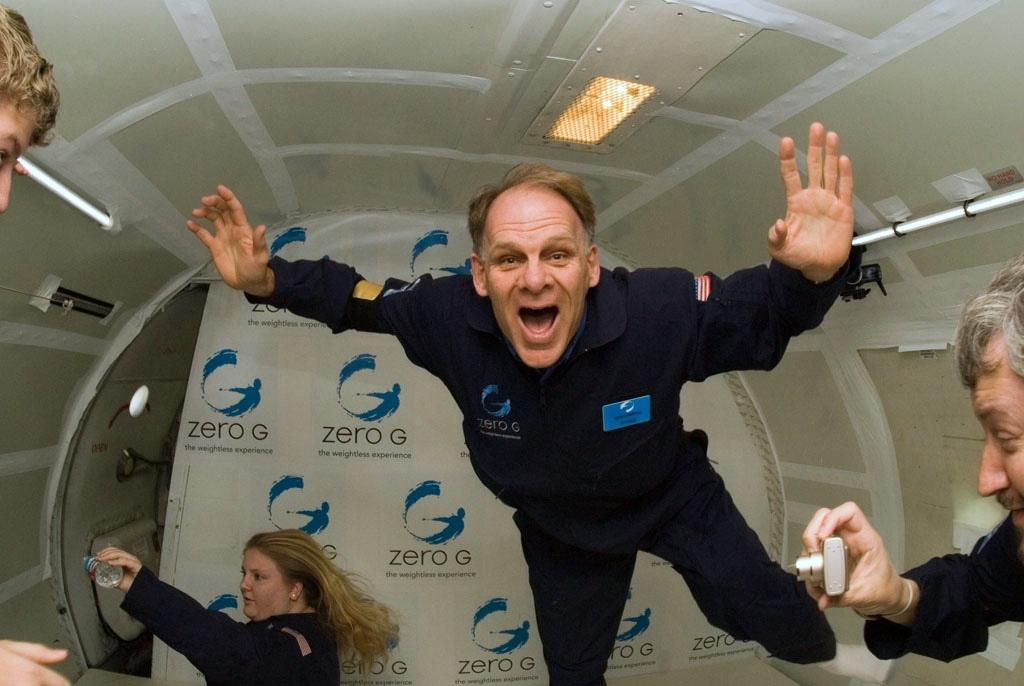How many people are in the image? There are people in the image. What is the man holding in the image? The man is holding a camera. What is the woman holding in the image? The woman is holding a bottle. What can be seen in the image that provides illumination? There are lights visible in the image. What object can be seen that is long and thin? There is a rod in the image. What is in the background of the image? There is a banner in the background of the image. What type of pail is being used to pump water in the image? There is no pail or water pumping activity present in the image. 